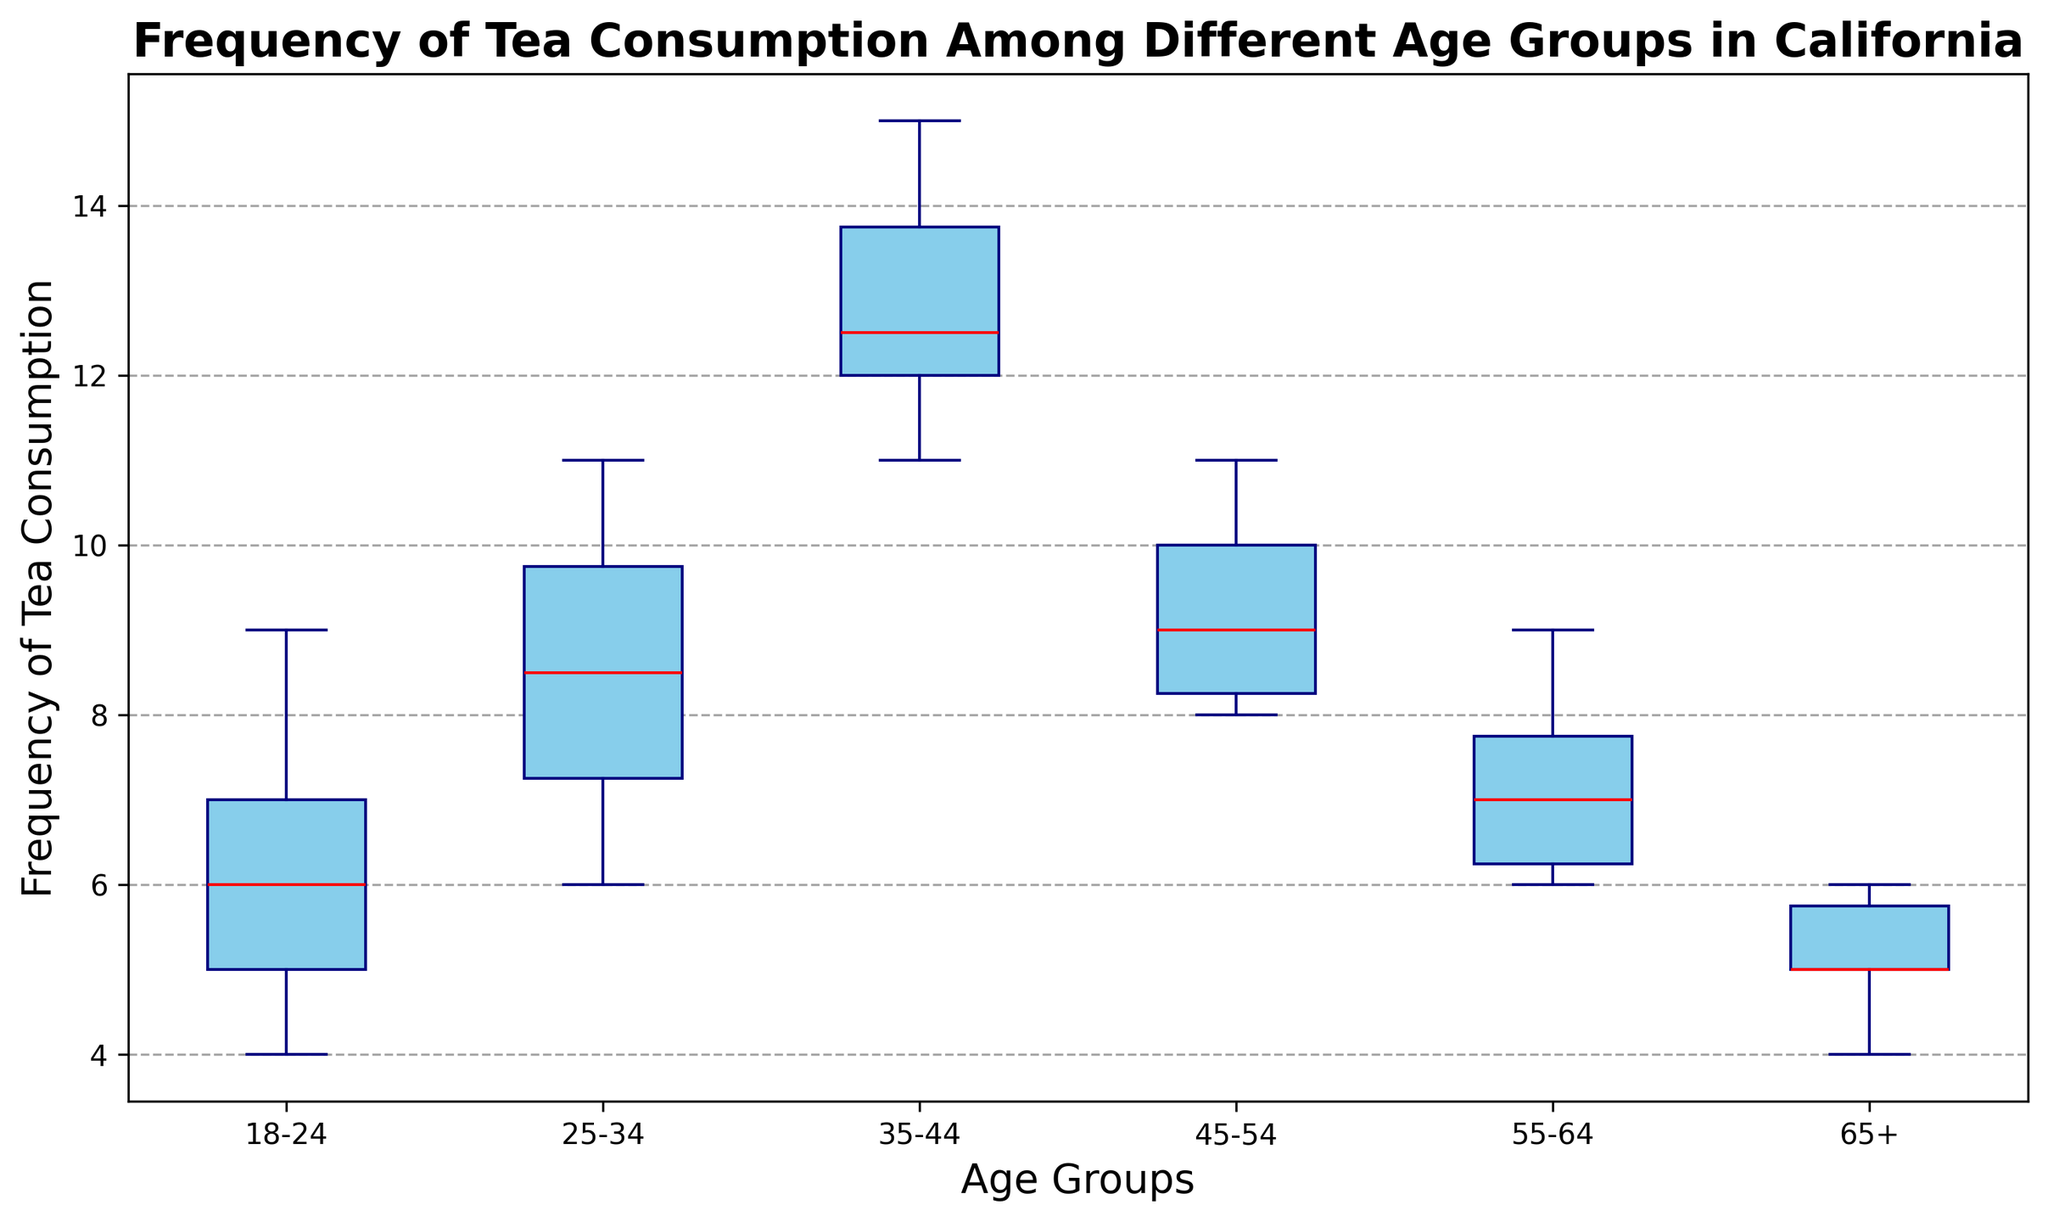What is the median frequency of tea consumption for the 25-34 age group? The box plot shows the median value as the line inside the box for each age group. The median for the 25-34 age group is the red line, which appears at 8.
Answer: 8 Which age group has the lowest median frequency of tea consumption? Compare the median lines (red) within each box. The median of the 65+ age group is at 5, which is lower than the medians of all other groups.
Answer: 65+ Is the variability in tea consumption higher in the 35-44 age group compared to the 55-64 age group? Variability is indicated by the length of the box, which represents the interquartile range (IQR). The box for 35-44 is visually wider than the box for 55-64, indicating higher variability.
Answer: Yes, higher in 35-44 What is the range of tea consumption for the 18-24 age group? The range is the difference between the maximum and minimum values shown by the whiskers of the box plot. For the 18-24 age group, the minimum is at 4 and the maximum is at 9. So, the range is 9 - 4 = 5.
Answer: 5 Which age group has the highest maximum frequency of tea consumption? The maximum value is indicated by the top whisker. The 35-44 age group has the highest whisker reaching up to 15.
Answer: 35-44 Are there any outliers in the 25-34 age group? Outliers are depicted as dots outside the whiskers. There are no dots outside the whiskers for the 25-34 age group, indicating no outliers.
Answer: No How does the median frequency of the 45-54 age group compare to the 55-64 age group? Compare the red lines inside the boxes. The median frequency for the 45-54 age group is 9, while for the 55-64 age group, it is 7. Therefore, the median is higher for the 45-54 group.
Answer: The median is higher in 45-54 What is the interquartile range (IQR) of tea consumption for the 18-24 age group? The IQR is the length of the box itself, which represents the middle 50% of data. Observing the box plot, the IQR for the 18-24 age group is the difference between the upper quartile (7) and the lower quartile (5). So, IQR = 7 - 5 = 2.
Answer: 2 Which age group has the narrowest range of tea consumption frequency data? The range is the distance between the top and bottom whiskers. The 65+ age group has the shortest whiskers, indicating the narrowest range (6-4 = 2).
Answer: 65+ 